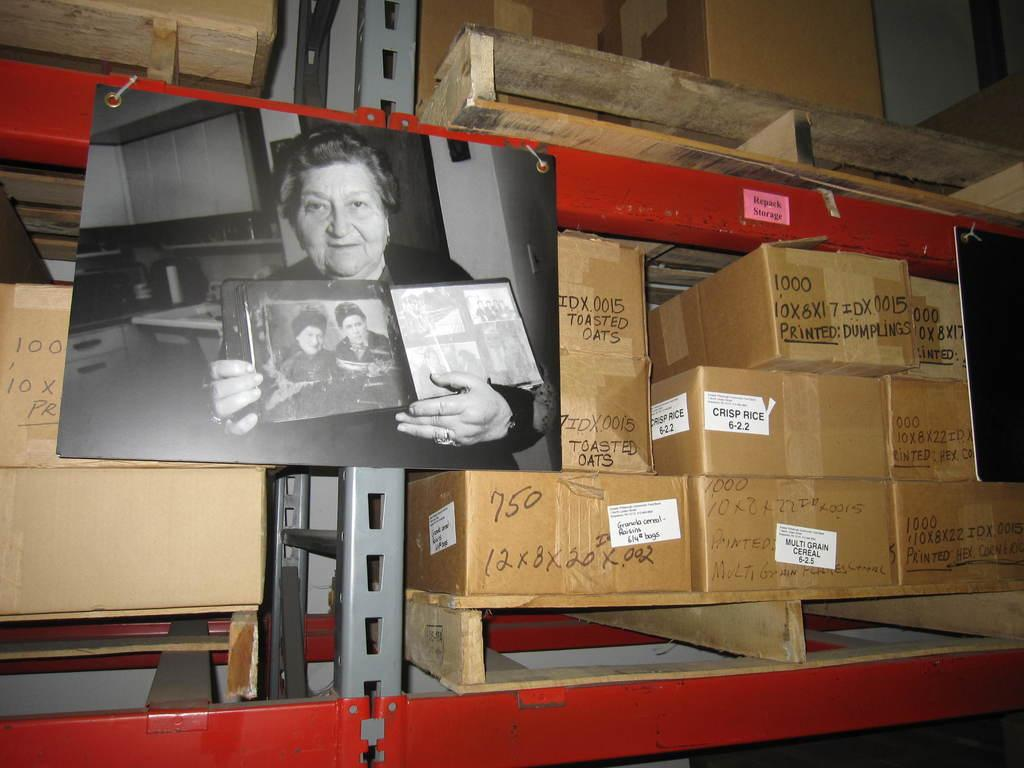<image>
Describe the image concisely. A box has the words toasted oats written on it in black marker. 